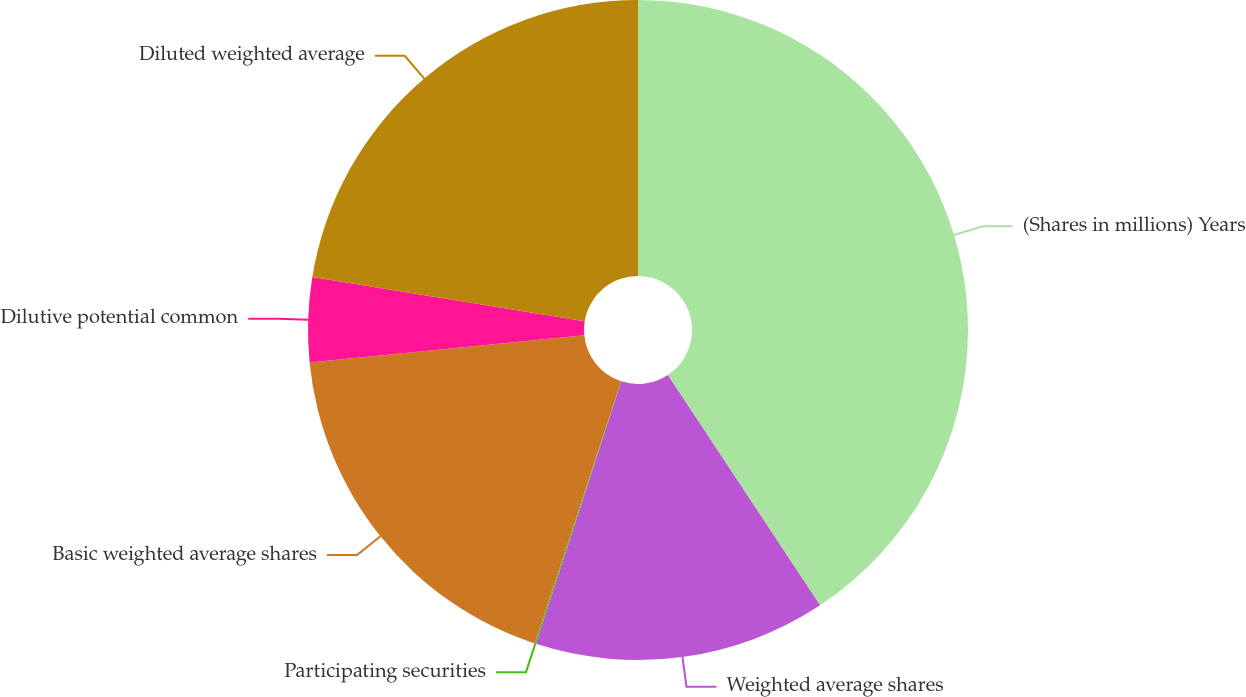Convert chart to OTSL. <chart><loc_0><loc_0><loc_500><loc_500><pie_chart><fcel>(Shares in millions) Years<fcel>Weighted average shares<fcel>Participating securities<fcel>Basic weighted average shares<fcel>Dilutive potential common<fcel>Diluted weighted average<nl><fcel>40.7%<fcel>14.3%<fcel>0.07%<fcel>18.36%<fcel>4.14%<fcel>22.43%<nl></chart> 